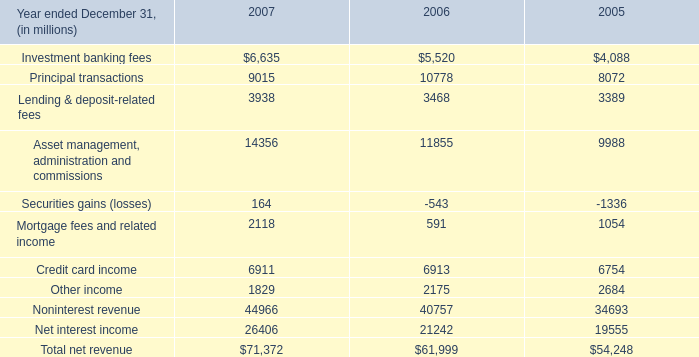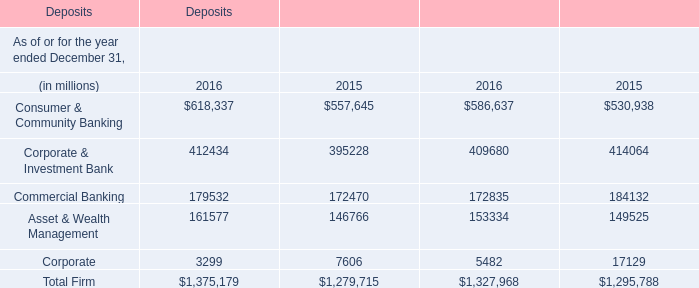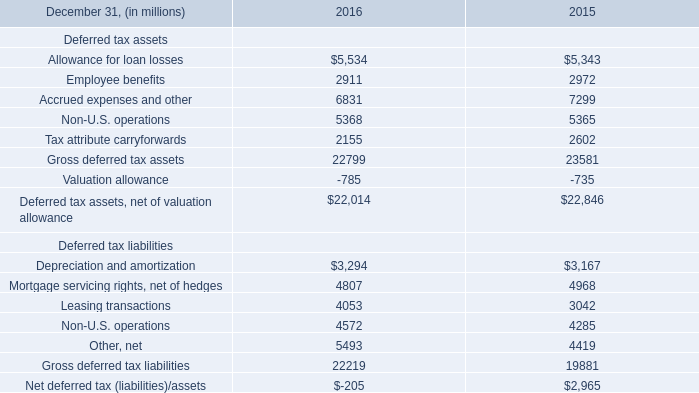What is the average value of Consumer & Community Banking and Allowance for loan losses in 2016 ? 
Computations: (((618337 + 5534) + 586637) / 3)
Answer: 403502.66667. 